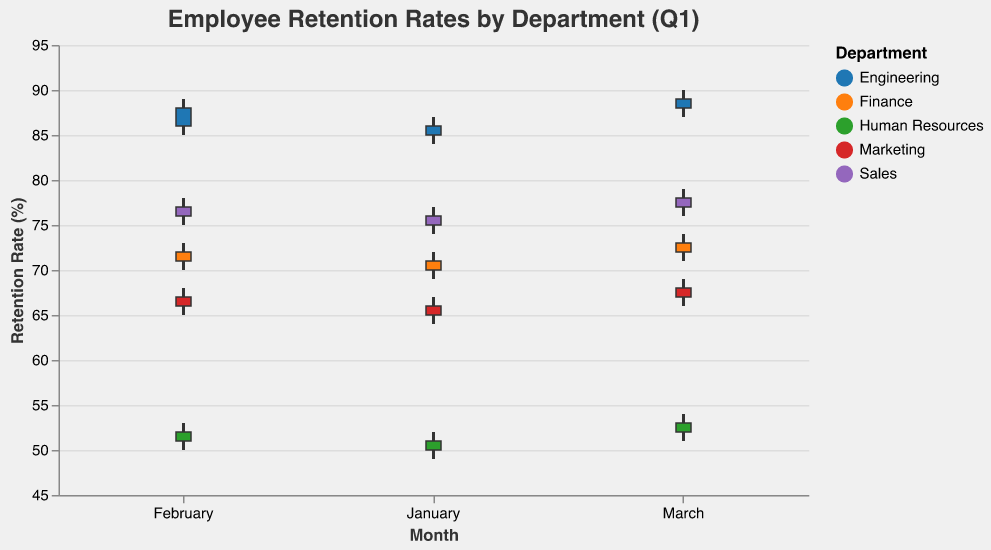How many departments are displayed in the figure? There are five departments shown in the data: Engineering, Sales, Marketing, Human Resources, and Finance.
Answer: 5 What is the retention rate for Engineering at the close of January? Find the 'Close' value for Engineering in January, which is 86%.
Answer: 86% Which department experienced the highest retention rate in March? Compare the 'High' values for each department in March. The highest value is 90%, which is for Engineering.
Answer: Engineering What was the difference between the highest and lowest retention rates for Sales in February? The 'High' value is 78% and the 'Low' value is 75%. So, the difference is 78 - 75 = 3%.
Answer: 3% Which department had the lowest opening retention rate in January? Compare the 'Open' values for each department in January. The lowest value is 50% for Human Resources.
Answer: Human Resources By how many percentage points did the retention rate for Finance change from January to March? The 'Close' value for January is 71% and for March is 73%. The change is 73 - 71 = 2%.
Answer: 2% For Marketing, what was the retention rate change from the opening rate to the closing rate in February? The 'Open' value is 66% and the 'Close' value is 67%. The change is 67 - 66 = 1%.
Answer: 1% In which month did Sales see the smallest variation in retention rate, and what was the variation? Calculate the difference between 'High' and 'Low' for each month. January: 77-74=3, February: 78-75=3, March: 79-76=3. All months have the same variation of 3%.
Answer: January, 3% What is the average closing retention rate for Marketing over the quarter? Sum the 'Close' values for Marketing (66 + 67 + 68) and divide by 3. The average is (66 + 67 + 68) / 3 = 67%.
Answer: 67% Which department had the most consistent retention rate (smallest range between 'Low' and 'High') overall? Compare the ranges ('High' minus 'Low') for each department. The smallest range is for Engineering, with a range of (90 - 84) = 6.
Answer: Engineering 